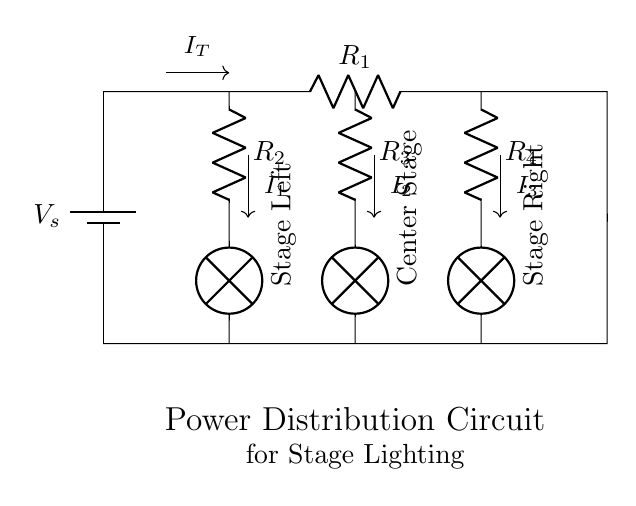What is the main power source? The main power source shown in the circuit is a battery, indicated as V_s. This is the component providing electrical energy to the circuit.
Answer: battery What type of circuit is this? This is a Current Divider circuit. It divides the total current into different paths through resistors, allowing to analyze how the current is distributed to the lamps.
Answer: Current Divider What does the component R_2 represent? R_2 represents the resistance for the first branch, which is supplying current to the lamp labeled as Stage Left. It is one of the resistors in the current divider configuration.
Answer: Resistor for Stage Left What is the total current (I_T) flowing into the circuit? The total current (I_T) is indicated by the label without a specific value shown on the circuit. The label implies it is the input current to the branches above.
Answer: I_T Which branch has the center stage lighting? The branch with the lamp labeled Center Stage is connected to the resistor R_3, indicating that this is the area designated for center stage lighting in the circuit.
Answer: Center Stage How many lamps are present in the circuit? There are three lamps present in the circuit, each corresponding to one of the three branches: Stage Left, Center Stage, and Stage Right.
Answer: Three What is the purpose of a current divider in this context? The purpose of the current divider in this lighting circuit is to distribute the total current through each branch (to each lamp) based on the resistance in each path, providing controlled lighting in different areas of the stage.
Answer: Distribute current 